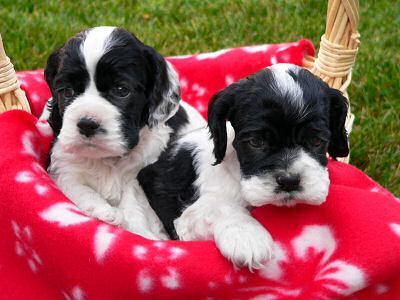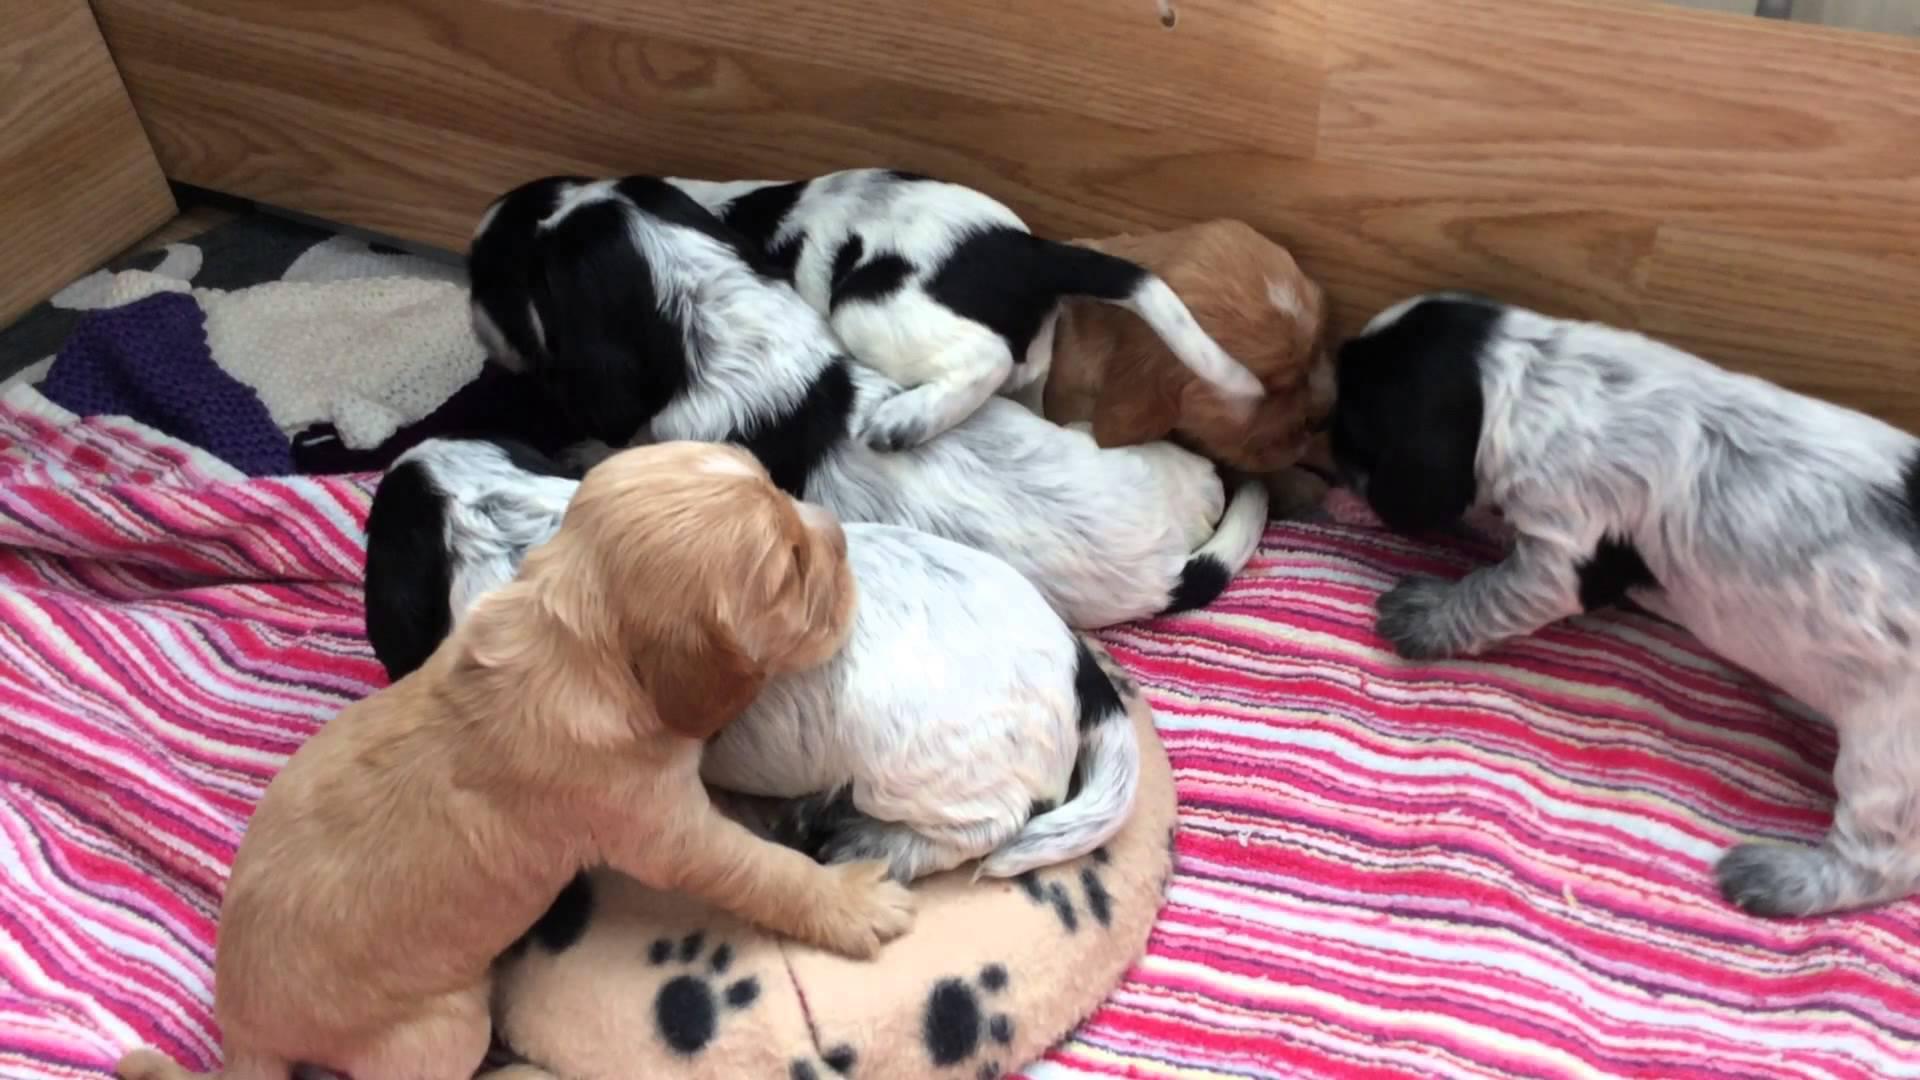The first image is the image on the left, the second image is the image on the right. Analyze the images presented: Is the assertion "A single puppy is lying on a carpet in one of the images." valid? Answer yes or no. No. 